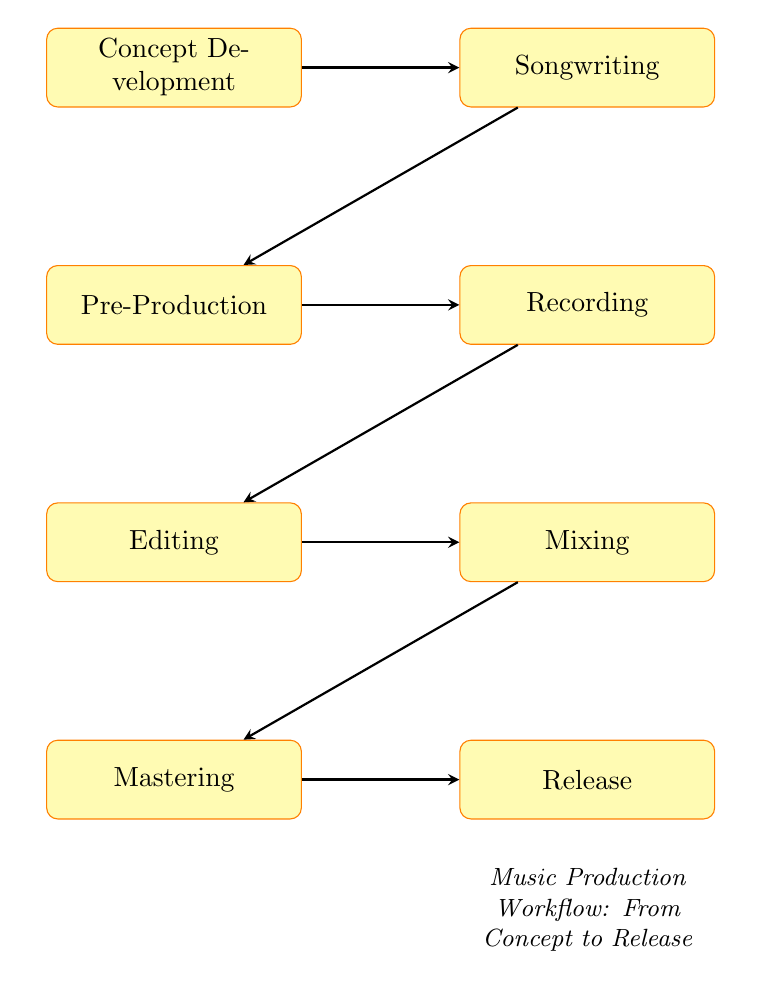What is the first step in the music production workflow? The first step in the workflow is Concept Development, as depicted in the diagram where it is the initial node.
Answer: Concept Development How many nodes are present in the diagram? The diagram contains a total of eight nodes, each representing a step in the music production workflow.
Answer: Eight What follows after the Songwriting step? According to the flow of the diagram, the step that comes after Songwriting is Pre-Production.
Answer: Pre-Production Which step includes arranging instrumentation? Pre-Production is the step that includes arranging instrumentation, as indicated in its key actions.
Answer: Pre-Production How many connections are there leading out from the Mixing step? The Mixing step has only one connection leading out to the next step, which is Mastering.
Answer: One Which step involves capturing performances? The step where performances are captured is Recording, which is shown as a step following Pre-Production according to the diagram.
Answer: Recording What is the final step before release? The last step before the Release is Mastering, as shown by the arrow leading to the Release node.
Answer: Mastering Which step directly precedes Editing? The step that directly comes before Editing is Recording, as illustrated by the arrows indicating the flow between these two processes.
Answer: Recording In what order do the steps occur from Concept Development to Release? The steps occur in the following order: Concept Development, Songwriting, Pre-Production, Recording, Editing, Mixing, Mastering, and then Release.
Answer: Concept Development, Songwriting, Pre-Production, Recording, Editing, Mixing, Mastering, Release 